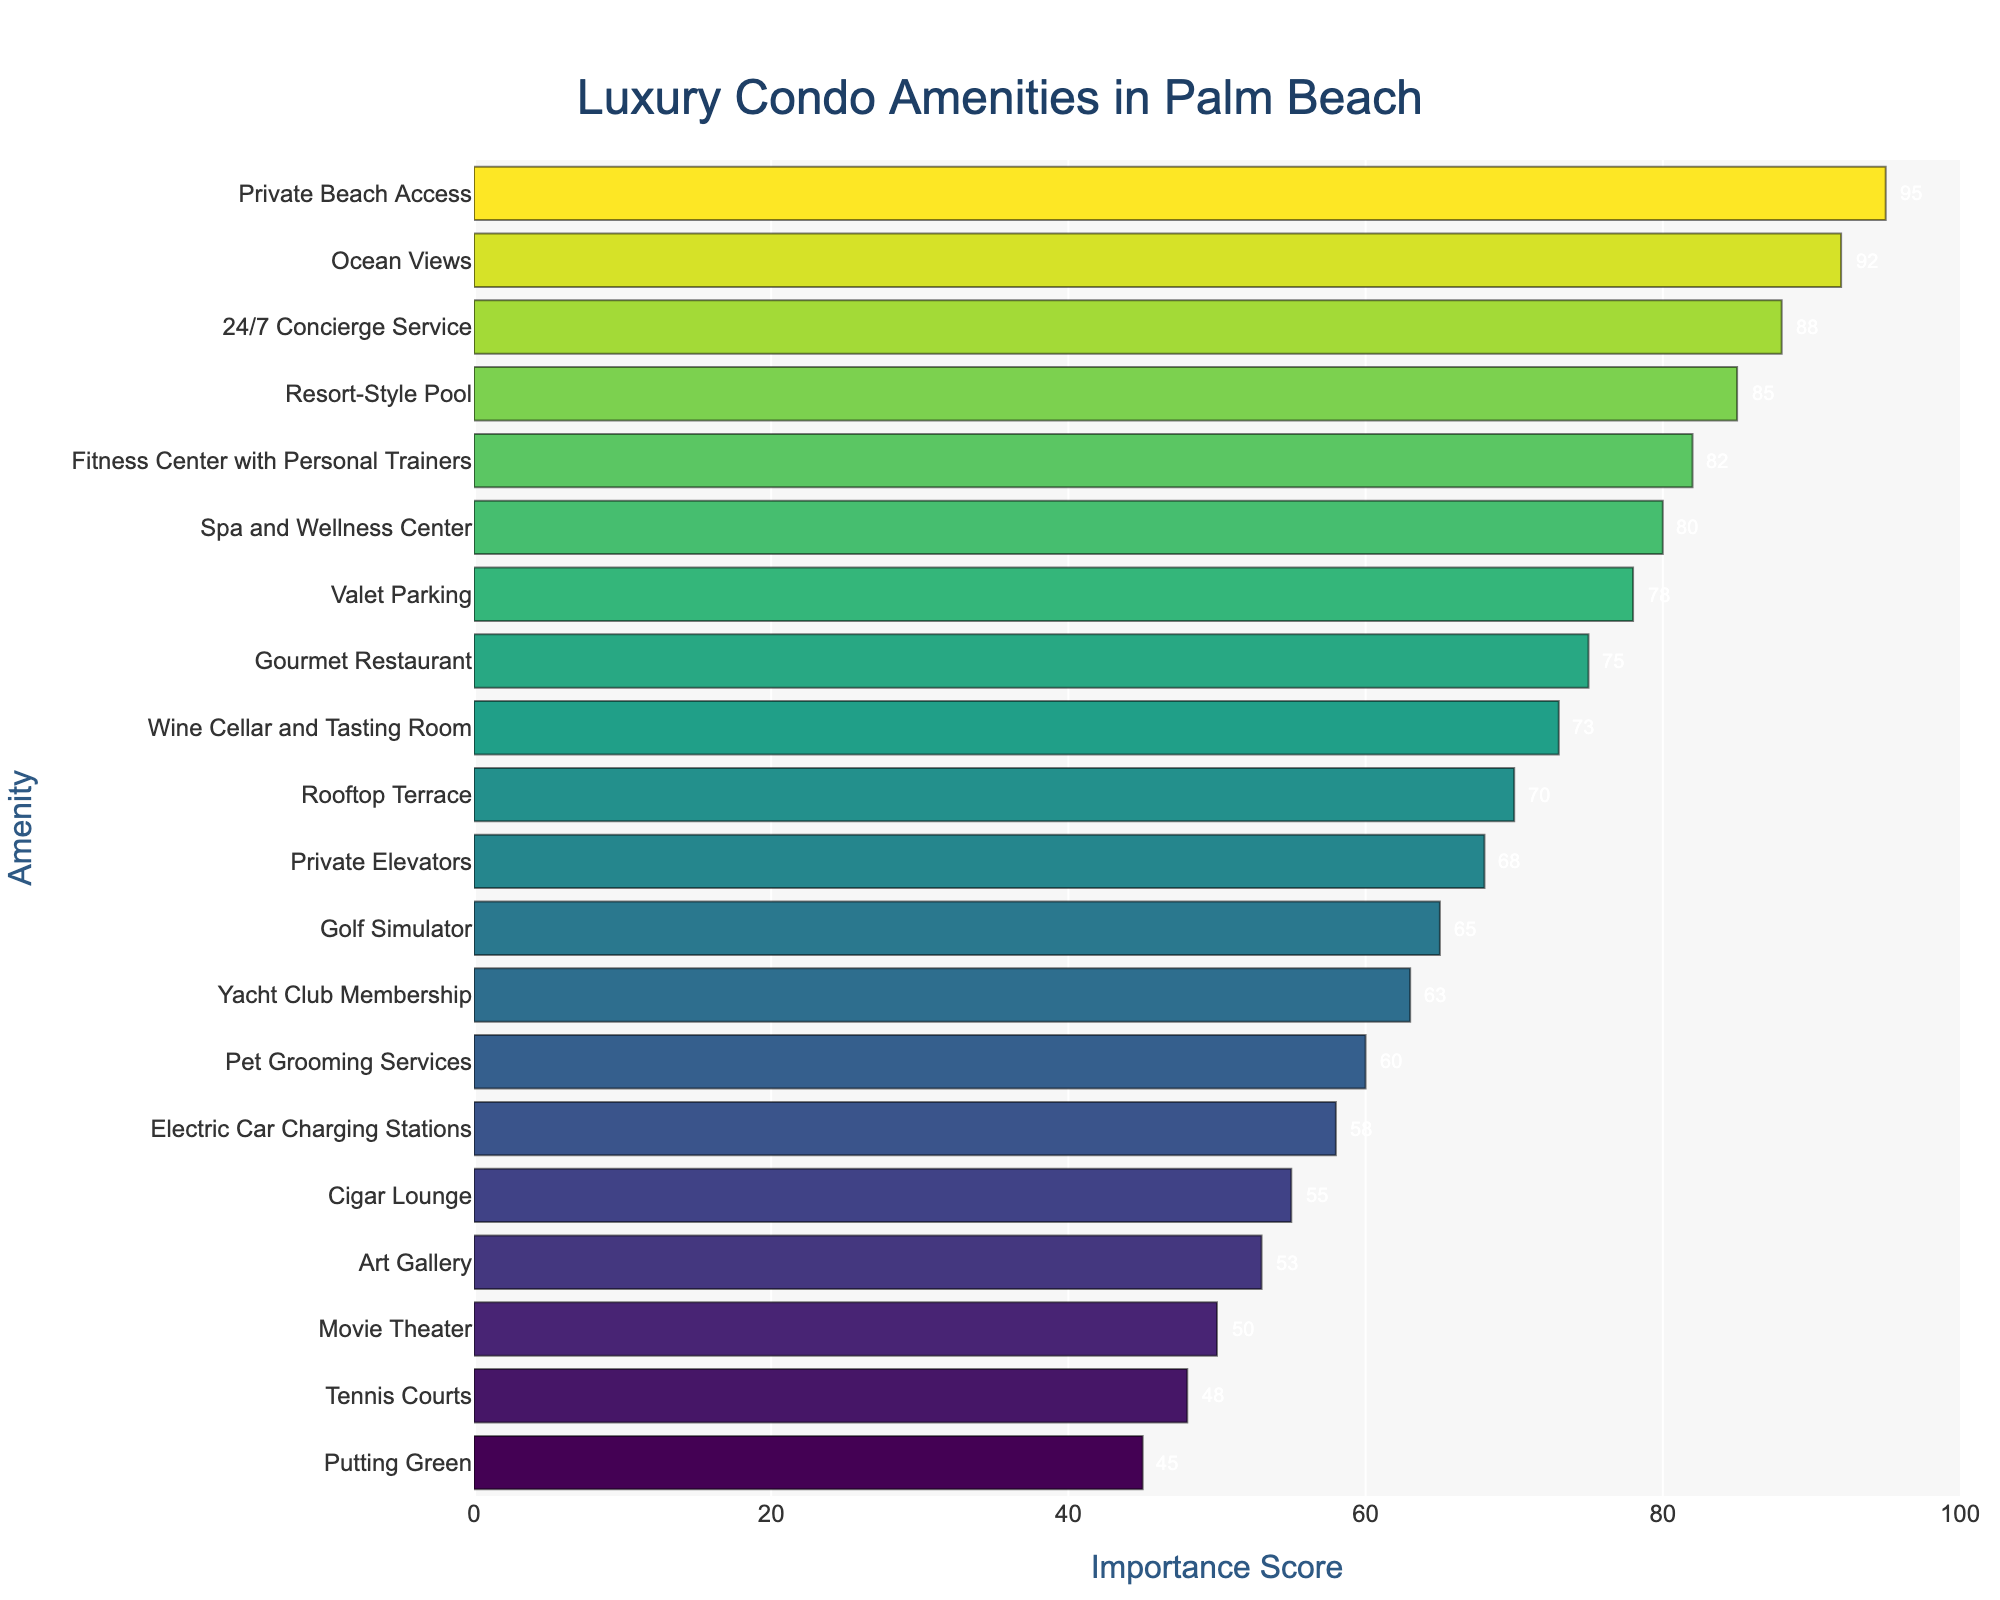What's the most important amenity for luxury condo buyers in Palm Beach? The bar chart shows the Importance Scores for each amenity. The highest score indicates the most important amenity, which is "Private Beach Access" with a score of 95.
Answer: Private Beach Access How much higher is the Importance Score of "Ocean Views" compared to "Fitness Center with Personal Trainers"? The chart shows "Ocean Views" with a score of 92 and "Fitness Center with Personal Trainers" with a score of 82. Subtract the Importance Score of the Fitness Center from the Importance Score of Ocean Views: 92 - 82 = 10.
Answer: 10 Which amenities have an Importance Score greater than 90? The chart displays scores for all amenities, and those with scores greater than 90 are "Private Beach Access" (95) and "Ocean Views" (92).
Answer: Private Beach Access, Ocean Views What is the total Importance Score of amenities related to food and beverage? Food and beverage-related amenities are "Gourmet Restaurant" (75) and "Wine Cellar and Tasting Room" (73). Add their Importance Scores: 75 + 73 = 148.
Answer: 148 What is the median Importance Score of all the amenities listed? To find the median, sort all the Importance Scores and find the middle value. Given 20 amenities, the median will be the average of the 10th and 11th scores in sorted order. The sorted scores are (45, 48, 50, 53, 55, 58, 60, 63, 65, 68, 70, 73, 75, 78, 80, 82, 85, 88, 92, 95). The 10th and 11th scores are 68 and 70, so the median is (68 + 70) / 2 = 69.
Answer: 69 Which has a higher Importance Score, "Spa and Wellness Center" or "Valet Parking"? The Importance Score for "Spa and Wellness Center" is 80, and for "Valet Parking" it is 78. Since 80 is greater than 78, "Spa and Wellness Center" has a higher score.
Answer: Spa and Wellness Center How many amenities have an Importance Score below 60? By observing the chart, the amenities with Importance Scores below 60 are "Cigar Lounge" (55), "Art Gallery" (53), "Movie Theater" (50), "Tennis Courts" (48), and "Putting Green" (45), totaling 5 amenities.
Answer: 5 Judging by the bars' lengths, does "Rooftop Terrace" have a longer bar than "Yacht Club Membership"? The chart shows "Rooftop Terrace" with an Importance Score of 70 and "Yacht Club Membership" with 63. Since 70 is greater than 63, "Rooftop Terrace" has a longer bar.
Answer: Yes What is the range of Importance Scores for these amenities? The range is calculated by subtracting the lowest score from the highest score. The highest score is 95 (Private Beach Access) and the lowest is 45 (Putting Green). So the range is 95 - 45 = 50.
Answer: 50 